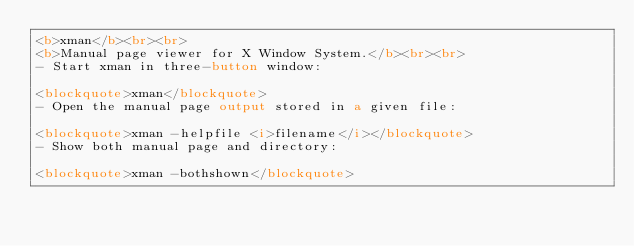<code> <loc_0><loc_0><loc_500><loc_500><_HTML_><b>xman</b><br><br>
<b>Manual page viewer for X Window System.</b><br><br>
- Start xman in three-button window:

<blockquote>xman</blockquote>
- Open the manual page output stored in a given file:

<blockquote>xman -helpfile <i>filename</i></blockquote>
- Show both manual page and directory:

<blockquote>xman -bothshown</blockquote>
</code> 